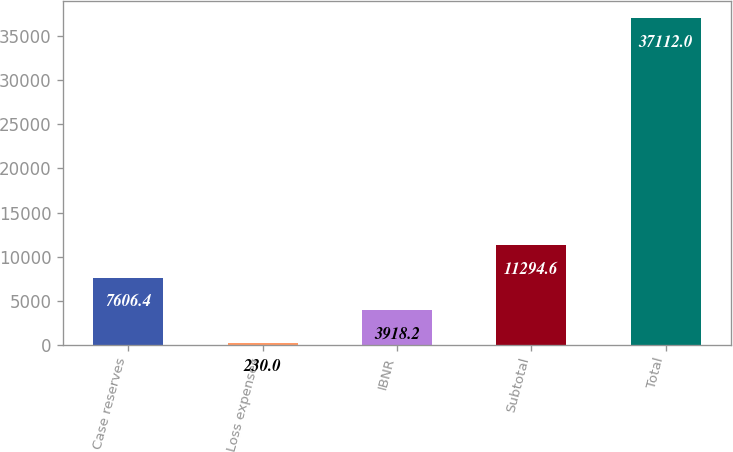<chart> <loc_0><loc_0><loc_500><loc_500><bar_chart><fcel>Case reserves<fcel>Loss expenses<fcel>IBNR<fcel>Subtotal<fcel>Total<nl><fcel>7606.4<fcel>230<fcel>3918.2<fcel>11294.6<fcel>37112<nl></chart> 